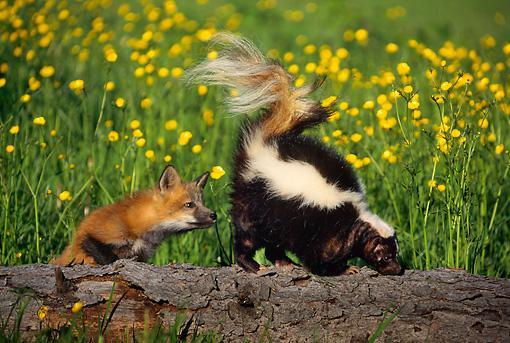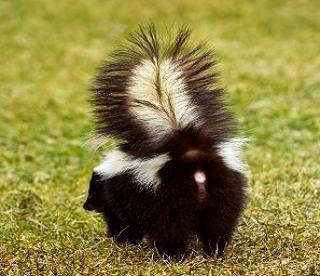The first image is the image on the left, the second image is the image on the right. For the images displayed, is the sentence "Both skunks are on the ground." factually correct? Answer yes or no. No. The first image is the image on the left, the second image is the image on the right. Examine the images to the left and right. Is the description "Each image contains one skunk with its tail raised, and at least one image features a skunk with its body, tail and head facing directly forward." accurate? Answer yes or no. No. 